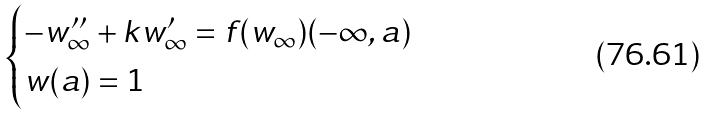Convert formula to latex. <formula><loc_0><loc_0><loc_500><loc_500>\begin{cases} - w _ { \infty } ^ { \prime \prime } + k w _ { \infty } ^ { \prime } = f ( w _ { \infty } ) ( - \infty , a ) \\ w ( a ) = 1 \end{cases}</formula> 